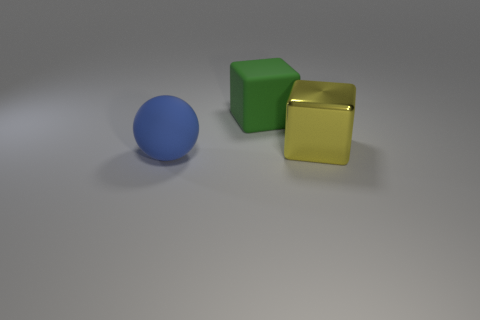Add 3 tiny red things. How many objects exist? 6 Subtract 1 yellow blocks. How many objects are left? 2 Subtract all blocks. How many objects are left? 1 Subtract 1 blocks. How many blocks are left? 1 Subtract all green blocks. Subtract all red cylinders. How many blocks are left? 1 Subtract all brown balls. How many yellow cubes are left? 1 Subtract all large purple matte cubes. Subtract all matte balls. How many objects are left? 2 Add 2 green rubber objects. How many green rubber objects are left? 3 Add 3 big yellow blocks. How many big yellow blocks exist? 4 